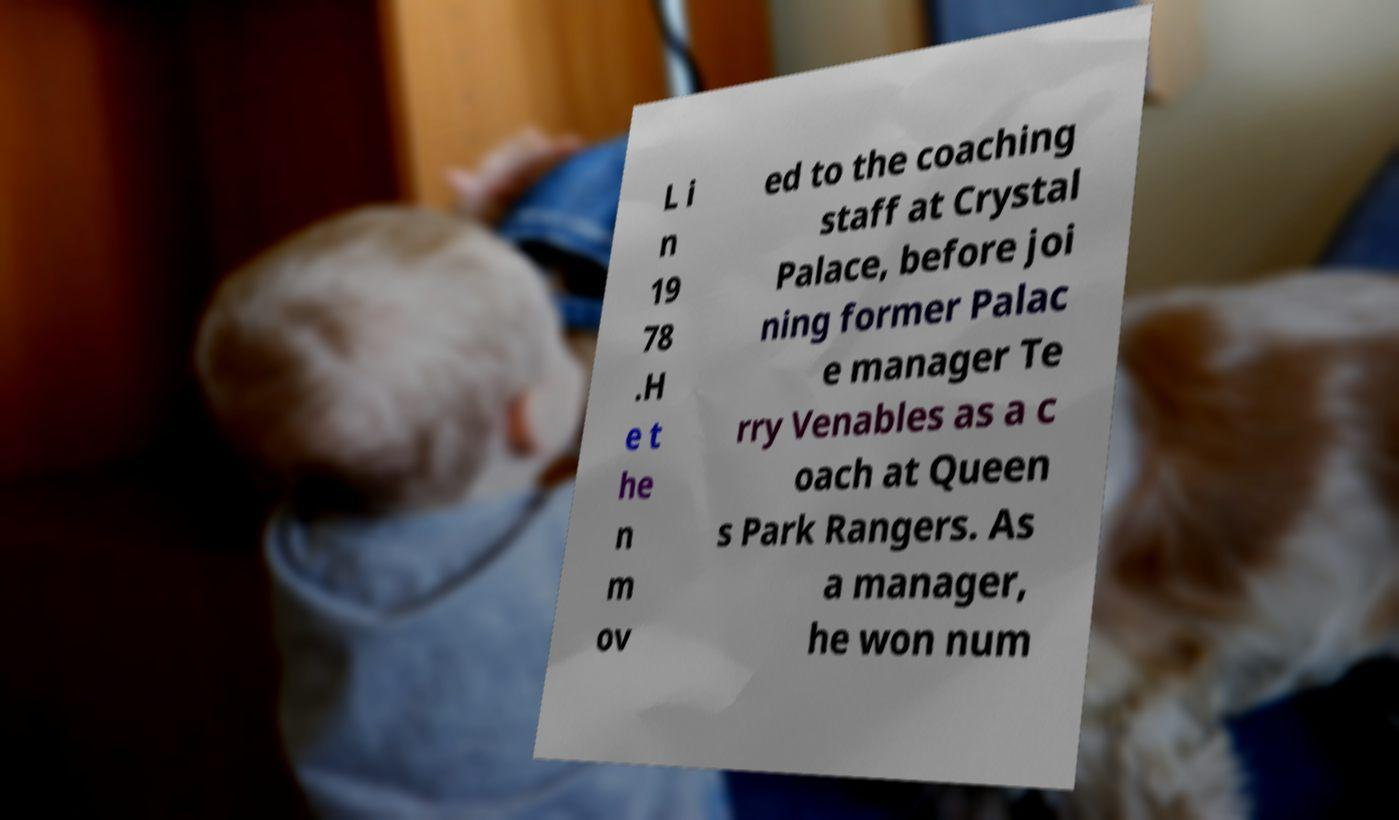For documentation purposes, I need the text within this image transcribed. Could you provide that? L i n 19 78 .H e t he n m ov ed to the coaching staff at Crystal Palace, before joi ning former Palac e manager Te rry Venables as a c oach at Queen s Park Rangers. As a manager, he won num 